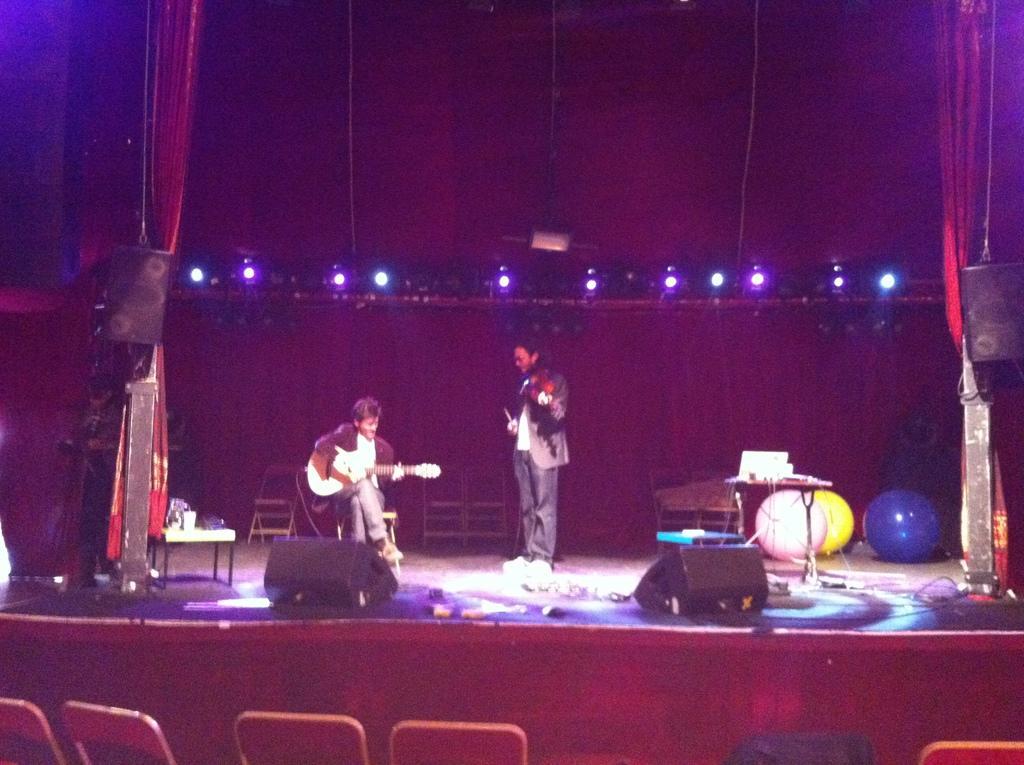In one or two sentences, can you explain what this image depicts? In this picture we can see two men, a man on the left side is playing a guitar, we can see chairs at the bottom, there are balloons here, we can see lights here, on the left side and right side we can see speakers. 